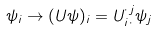Convert formula to latex. <formula><loc_0><loc_0><loc_500><loc_500>\psi _ { i } \rightarrow ( U \psi ) _ { i } = U _ { i \, \cdot } ^ { \cdot \, j } \psi _ { j }</formula> 